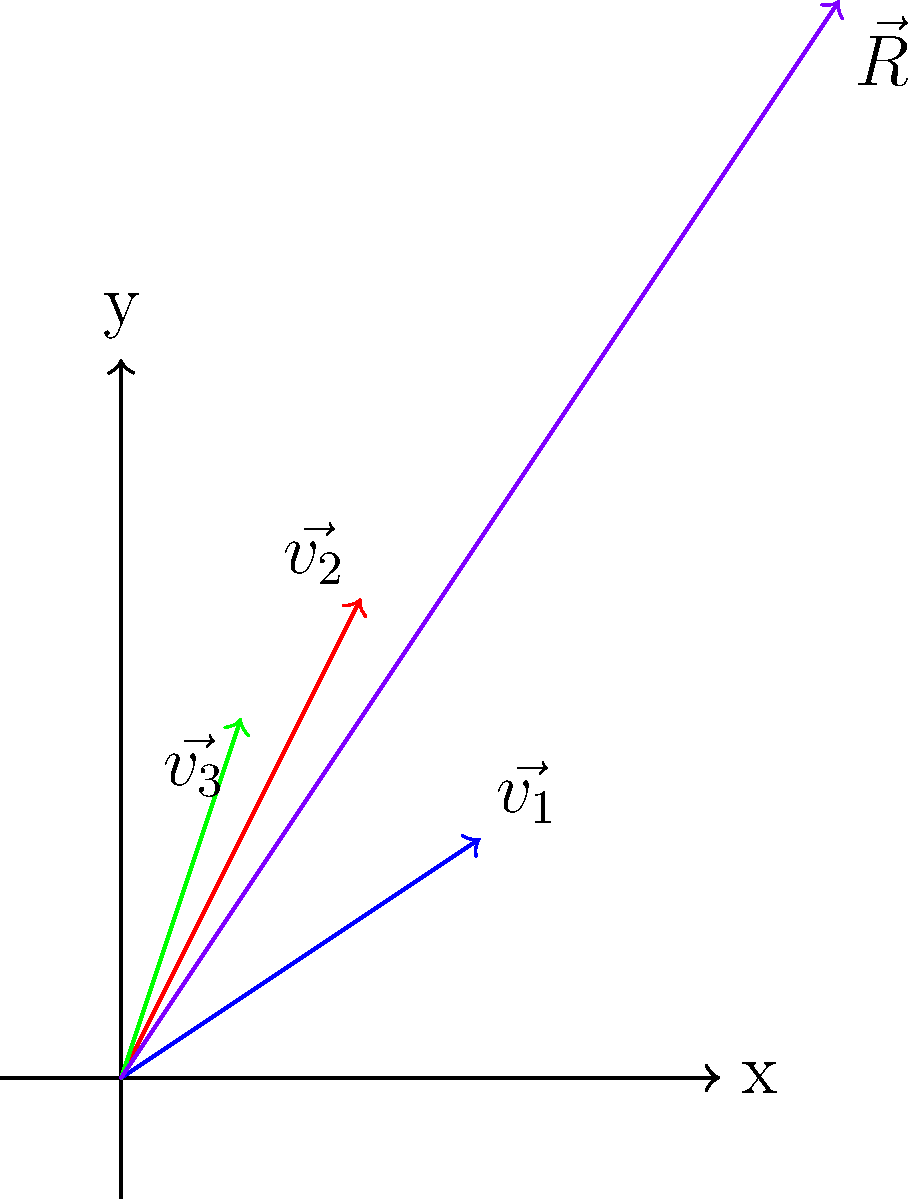As a celebrity guest on the radio show, you're discussing the impact of social media influencers. Three celebrities, represented by vectors $\vec{v_1} = (3,2)$, $\vec{v_2} = (2,4)$, and $\vec{v_3} = (1,3)$, are known to affect social media trends. If their influences combine, what is the magnitude of the resulting trend vector $\vec{R}$, rounded to the nearest whole number? To solve this problem, we'll follow these steps:

1) First, we need to add the three vectors to find the resultant vector $\vec{R}$:

   $\vec{R} = \vec{v_1} + \vec{v_2} + \vec{v_3}$

2) Adding the x-components:
   $R_x = 3 + 2 + 1 = 6$

3) Adding the y-components:
   $R_y = 2 + 4 + 3 = 9$

4) So, the resultant vector is $\vec{R} = (6,9)$

5) To find the magnitude of $\vec{R}$, we use the Pythagorean theorem:

   $|\vec{R}| = \sqrt{R_x^2 + R_y^2}$

6) Substituting the values:

   $|\vec{R}| = \sqrt{6^2 + 9^2} = \sqrt{36 + 81} = \sqrt{117}$

7) Calculate and round to the nearest whole number:

   $\sqrt{117} \approx 10.82 \approx 11$

Therefore, the magnitude of the resulting trend vector, rounded to the nearest whole number, is 11.
Answer: 11 